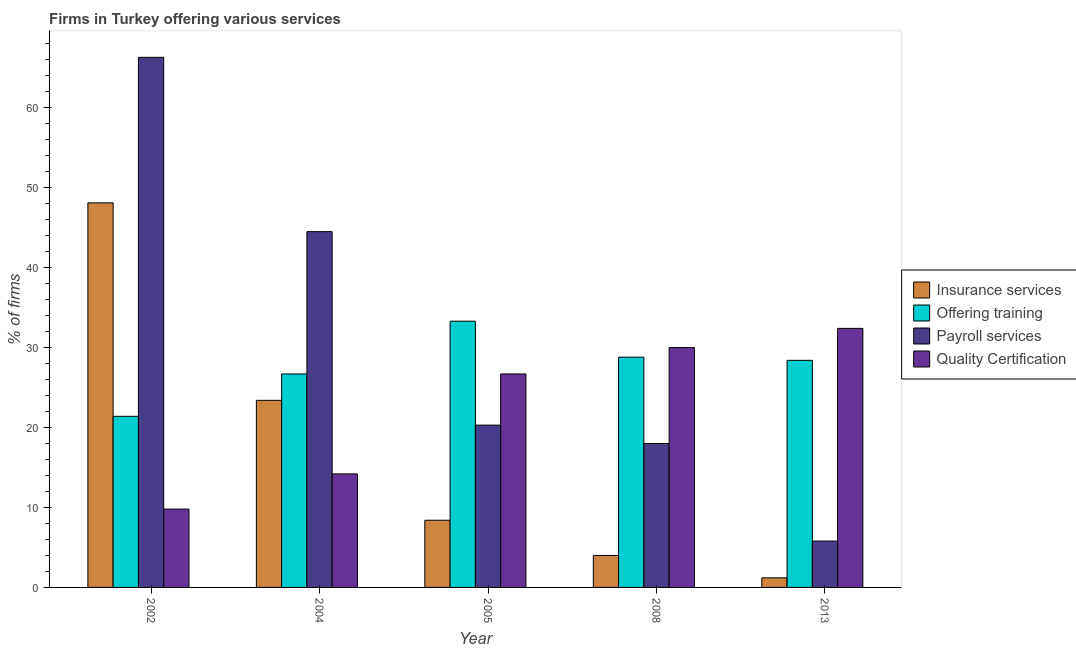How many different coloured bars are there?
Your response must be concise. 4. How many groups of bars are there?
Offer a very short reply. 5. How many bars are there on the 1st tick from the right?
Offer a very short reply. 4. What is the label of the 5th group of bars from the left?
Offer a terse response. 2013. In how many cases, is the number of bars for a given year not equal to the number of legend labels?
Your answer should be very brief. 0. What is the percentage of firms offering payroll services in 2002?
Ensure brevity in your answer.  66.3. Across all years, what is the maximum percentage of firms offering quality certification?
Provide a succinct answer. 32.4. Across all years, what is the minimum percentage of firms offering payroll services?
Offer a terse response. 5.8. In which year was the percentage of firms offering payroll services maximum?
Your answer should be very brief. 2002. In which year was the percentage of firms offering quality certification minimum?
Your response must be concise. 2002. What is the total percentage of firms offering training in the graph?
Make the answer very short. 138.6. What is the difference between the percentage of firms offering quality certification in 2005 and that in 2013?
Your answer should be compact. -5.7. What is the difference between the percentage of firms offering payroll services in 2008 and the percentage of firms offering insurance services in 2004?
Provide a succinct answer. -26.5. What is the average percentage of firms offering payroll services per year?
Offer a terse response. 30.98. In how many years, is the percentage of firms offering insurance services greater than 26 %?
Give a very brief answer. 1. What is the ratio of the percentage of firms offering insurance services in 2002 to that in 2005?
Keep it short and to the point. 5.73. Is the percentage of firms offering quality certification in 2002 less than that in 2013?
Provide a short and direct response. Yes. Is the difference between the percentage of firms offering payroll services in 2002 and 2008 greater than the difference between the percentage of firms offering quality certification in 2002 and 2008?
Your answer should be very brief. No. What is the difference between the highest and the second highest percentage of firms offering quality certification?
Ensure brevity in your answer.  2.4. What is the difference between the highest and the lowest percentage of firms offering insurance services?
Your response must be concise. 46.9. Is it the case that in every year, the sum of the percentage of firms offering training and percentage of firms offering insurance services is greater than the sum of percentage of firms offering payroll services and percentage of firms offering quality certification?
Make the answer very short. No. What does the 1st bar from the left in 2008 represents?
Provide a short and direct response. Insurance services. What does the 2nd bar from the right in 2008 represents?
Your answer should be compact. Payroll services. How many bars are there?
Ensure brevity in your answer.  20. Does the graph contain any zero values?
Your answer should be very brief. No. Where does the legend appear in the graph?
Provide a succinct answer. Center right. What is the title of the graph?
Your response must be concise. Firms in Turkey offering various services . What is the label or title of the X-axis?
Make the answer very short. Year. What is the label or title of the Y-axis?
Offer a very short reply. % of firms. What is the % of firms in Insurance services in 2002?
Provide a short and direct response. 48.1. What is the % of firms in Offering training in 2002?
Offer a terse response. 21.4. What is the % of firms of Payroll services in 2002?
Provide a succinct answer. 66.3. What is the % of firms in Quality Certification in 2002?
Offer a terse response. 9.8. What is the % of firms of Insurance services in 2004?
Offer a terse response. 23.4. What is the % of firms in Offering training in 2004?
Provide a short and direct response. 26.7. What is the % of firms of Payroll services in 2004?
Make the answer very short. 44.5. What is the % of firms in Insurance services in 2005?
Keep it short and to the point. 8.4. What is the % of firms of Offering training in 2005?
Your response must be concise. 33.3. What is the % of firms in Payroll services in 2005?
Give a very brief answer. 20.3. What is the % of firms of Quality Certification in 2005?
Make the answer very short. 26.7. What is the % of firms in Offering training in 2008?
Give a very brief answer. 28.8. What is the % of firms of Payroll services in 2008?
Your answer should be compact. 18. What is the % of firms of Insurance services in 2013?
Your answer should be compact. 1.2. What is the % of firms of Offering training in 2013?
Your response must be concise. 28.4. What is the % of firms in Quality Certification in 2013?
Keep it short and to the point. 32.4. Across all years, what is the maximum % of firms in Insurance services?
Your answer should be very brief. 48.1. Across all years, what is the maximum % of firms in Offering training?
Your answer should be compact. 33.3. Across all years, what is the maximum % of firms in Payroll services?
Provide a succinct answer. 66.3. Across all years, what is the maximum % of firms in Quality Certification?
Keep it short and to the point. 32.4. Across all years, what is the minimum % of firms of Offering training?
Offer a very short reply. 21.4. Across all years, what is the minimum % of firms of Payroll services?
Ensure brevity in your answer.  5.8. Across all years, what is the minimum % of firms in Quality Certification?
Your response must be concise. 9.8. What is the total % of firms in Insurance services in the graph?
Provide a succinct answer. 85.1. What is the total % of firms in Offering training in the graph?
Make the answer very short. 138.6. What is the total % of firms in Payroll services in the graph?
Give a very brief answer. 154.9. What is the total % of firms in Quality Certification in the graph?
Your answer should be very brief. 113.1. What is the difference between the % of firms in Insurance services in 2002 and that in 2004?
Provide a succinct answer. 24.7. What is the difference between the % of firms of Payroll services in 2002 and that in 2004?
Ensure brevity in your answer.  21.8. What is the difference between the % of firms of Quality Certification in 2002 and that in 2004?
Your answer should be very brief. -4.4. What is the difference between the % of firms of Insurance services in 2002 and that in 2005?
Give a very brief answer. 39.7. What is the difference between the % of firms of Offering training in 2002 and that in 2005?
Give a very brief answer. -11.9. What is the difference between the % of firms of Quality Certification in 2002 and that in 2005?
Your answer should be very brief. -16.9. What is the difference between the % of firms of Insurance services in 2002 and that in 2008?
Give a very brief answer. 44.1. What is the difference between the % of firms in Offering training in 2002 and that in 2008?
Provide a succinct answer. -7.4. What is the difference between the % of firms of Payroll services in 2002 and that in 2008?
Your answer should be compact. 48.3. What is the difference between the % of firms in Quality Certification in 2002 and that in 2008?
Your answer should be very brief. -20.2. What is the difference between the % of firms in Insurance services in 2002 and that in 2013?
Give a very brief answer. 46.9. What is the difference between the % of firms in Payroll services in 2002 and that in 2013?
Your answer should be compact. 60.5. What is the difference between the % of firms in Quality Certification in 2002 and that in 2013?
Offer a terse response. -22.6. What is the difference between the % of firms of Offering training in 2004 and that in 2005?
Offer a very short reply. -6.6. What is the difference between the % of firms in Payroll services in 2004 and that in 2005?
Your answer should be very brief. 24.2. What is the difference between the % of firms in Quality Certification in 2004 and that in 2005?
Keep it short and to the point. -12.5. What is the difference between the % of firms in Insurance services in 2004 and that in 2008?
Keep it short and to the point. 19.4. What is the difference between the % of firms in Quality Certification in 2004 and that in 2008?
Your answer should be very brief. -15.8. What is the difference between the % of firms of Offering training in 2004 and that in 2013?
Your response must be concise. -1.7. What is the difference between the % of firms in Payroll services in 2004 and that in 2013?
Give a very brief answer. 38.7. What is the difference between the % of firms of Quality Certification in 2004 and that in 2013?
Offer a terse response. -18.2. What is the difference between the % of firms of Offering training in 2005 and that in 2008?
Your answer should be compact. 4.5. What is the difference between the % of firms in Offering training in 2005 and that in 2013?
Ensure brevity in your answer.  4.9. What is the difference between the % of firms in Quality Certification in 2005 and that in 2013?
Make the answer very short. -5.7. What is the difference between the % of firms of Insurance services in 2008 and that in 2013?
Your answer should be very brief. 2.8. What is the difference between the % of firms in Offering training in 2008 and that in 2013?
Your response must be concise. 0.4. What is the difference between the % of firms of Payroll services in 2008 and that in 2013?
Make the answer very short. 12.2. What is the difference between the % of firms in Quality Certification in 2008 and that in 2013?
Your answer should be compact. -2.4. What is the difference between the % of firms of Insurance services in 2002 and the % of firms of Offering training in 2004?
Keep it short and to the point. 21.4. What is the difference between the % of firms of Insurance services in 2002 and the % of firms of Quality Certification in 2004?
Give a very brief answer. 33.9. What is the difference between the % of firms in Offering training in 2002 and the % of firms in Payroll services in 2004?
Make the answer very short. -23.1. What is the difference between the % of firms of Offering training in 2002 and the % of firms of Quality Certification in 2004?
Ensure brevity in your answer.  7.2. What is the difference between the % of firms in Payroll services in 2002 and the % of firms in Quality Certification in 2004?
Your answer should be very brief. 52.1. What is the difference between the % of firms of Insurance services in 2002 and the % of firms of Offering training in 2005?
Offer a very short reply. 14.8. What is the difference between the % of firms in Insurance services in 2002 and the % of firms in Payroll services in 2005?
Ensure brevity in your answer.  27.8. What is the difference between the % of firms of Insurance services in 2002 and the % of firms of Quality Certification in 2005?
Ensure brevity in your answer.  21.4. What is the difference between the % of firms in Payroll services in 2002 and the % of firms in Quality Certification in 2005?
Offer a very short reply. 39.6. What is the difference between the % of firms of Insurance services in 2002 and the % of firms of Offering training in 2008?
Give a very brief answer. 19.3. What is the difference between the % of firms in Insurance services in 2002 and the % of firms in Payroll services in 2008?
Keep it short and to the point. 30.1. What is the difference between the % of firms of Insurance services in 2002 and the % of firms of Quality Certification in 2008?
Keep it short and to the point. 18.1. What is the difference between the % of firms in Offering training in 2002 and the % of firms in Payroll services in 2008?
Make the answer very short. 3.4. What is the difference between the % of firms of Offering training in 2002 and the % of firms of Quality Certification in 2008?
Make the answer very short. -8.6. What is the difference between the % of firms in Payroll services in 2002 and the % of firms in Quality Certification in 2008?
Give a very brief answer. 36.3. What is the difference between the % of firms in Insurance services in 2002 and the % of firms in Payroll services in 2013?
Ensure brevity in your answer.  42.3. What is the difference between the % of firms of Offering training in 2002 and the % of firms of Quality Certification in 2013?
Give a very brief answer. -11. What is the difference between the % of firms of Payroll services in 2002 and the % of firms of Quality Certification in 2013?
Make the answer very short. 33.9. What is the difference between the % of firms in Insurance services in 2004 and the % of firms in Offering training in 2005?
Offer a very short reply. -9.9. What is the difference between the % of firms in Insurance services in 2004 and the % of firms in Quality Certification in 2005?
Offer a terse response. -3.3. What is the difference between the % of firms in Insurance services in 2004 and the % of firms in Offering training in 2008?
Provide a short and direct response. -5.4. What is the difference between the % of firms of Insurance services in 2004 and the % of firms of Payroll services in 2008?
Provide a succinct answer. 5.4. What is the difference between the % of firms of Offering training in 2004 and the % of firms of Payroll services in 2008?
Make the answer very short. 8.7. What is the difference between the % of firms in Insurance services in 2004 and the % of firms in Payroll services in 2013?
Provide a short and direct response. 17.6. What is the difference between the % of firms of Insurance services in 2004 and the % of firms of Quality Certification in 2013?
Your answer should be compact. -9. What is the difference between the % of firms of Offering training in 2004 and the % of firms of Payroll services in 2013?
Offer a very short reply. 20.9. What is the difference between the % of firms in Insurance services in 2005 and the % of firms in Offering training in 2008?
Your answer should be compact. -20.4. What is the difference between the % of firms in Insurance services in 2005 and the % of firms in Payroll services in 2008?
Ensure brevity in your answer.  -9.6. What is the difference between the % of firms in Insurance services in 2005 and the % of firms in Quality Certification in 2008?
Your response must be concise. -21.6. What is the difference between the % of firms in Offering training in 2005 and the % of firms in Quality Certification in 2008?
Provide a short and direct response. 3.3. What is the difference between the % of firms of Offering training in 2005 and the % of firms of Payroll services in 2013?
Ensure brevity in your answer.  27.5. What is the difference between the % of firms in Payroll services in 2005 and the % of firms in Quality Certification in 2013?
Offer a terse response. -12.1. What is the difference between the % of firms of Insurance services in 2008 and the % of firms of Offering training in 2013?
Provide a succinct answer. -24.4. What is the difference between the % of firms of Insurance services in 2008 and the % of firms of Quality Certification in 2013?
Keep it short and to the point. -28.4. What is the difference between the % of firms in Offering training in 2008 and the % of firms in Payroll services in 2013?
Your answer should be compact. 23. What is the difference between the % of firms of Payroll services in 2008 and the % of firms of Quality Certification in 2013?
Give a very brief answer. -14.4. What is the average % of firms in Insurance services per year?
Provide a short and direct response. 17.02. What is the average % of firms in Offering training per year?
Offer a very short reply. 27.72. What is the average % of firms in Payroll services per year?
Ensure brevity in your answer.  30.98. What is the average % of firms of Quality Certification per year?
Keep it short and to the point. 22.62. In the year 2002, what is the difference between the % of firms in Insurance services and % of firms in Offering training?
Keep it short and to the point. 26.7. In the year 2002, what is the difference between the % of firms in Insurance services and % of firms in Payroll services?
Offer a very short reply. -18.2. In the year 2002, what is the difference between the % of firms in Insurance services and % of firms in Quality Certification?
Ensure brevity in your answer.  38.3. In the year 2002, what is the difference between the % of firms of Offering training and % of firms of Payroll services?
Keep it short and to the point. -44.9. In the year 2002, what is the difference between the % of firms of Payroll services and % of firms of Quality Certification?
Offer a terse response. 56.5. In the year 2004, what is the difference between the % of firms in Insurance services and % of firms in Payroll services?
Make the answer very short. -21.1. In the year 2004, what is the difference between the % of firms of Offering training and % of firms of Payroll services?
Give a very brief answer. -17.8. In the year 2004, what is the difference between the % of firms of Offering training and % of firms of Quality Certification?
Offer a very short reply. 12.5. In the year 2004, what is the difference between the % of firms of Payroll services and % of firms of Quality Certification?
Offer a very short reply. 30.3. In the year 2005, what is the difference between the % of firms of Insurance services and % of firms of Offering training?
Ensure brevity in your answer.  -24.9. In the year 2005, what is the difference between the % of firms in Insurance services and % of firms in Payroll services?
Give a very brief answer. -11.9. In the year 2005, what is the difference between the % of firms of Insurance services and % of firms of Quality Certification?
Your response must be concise. -18.3. In the year 2005, what is the difference between the % of firms of Offering training and % of firms of Payroll services?
Make the answer very short. 13. In the year 2005, what is the difference between the % of firms in Payroll services and % of firms in Quality Certification?
Give a very brief answer. -6.4. In the year 2008, what is the difference between the % of firms in Insurance services and % of firms in Offering training?
Keep it short and to the point. -24.8. In the year 2008, what is the difference between the % of firms of Insurance services and % of firms of Quality Certification?
Offer a very short reply. -26. In the year 2008, what is the difference between the % of firms in Offering training and % of firms in Quality Certification?
Your answer should be compact. -1.2. In the year 2008, what is the difference between the % of firms in Payroll services and % of firms in Quality Certification?
Provide a succinct answer. -12. In the year 2013, what is the difference between the % of firms of Insurance services and % of firms of Offering training?
Offer a terse response. -27.2. In the year 2013, what is the difference between the % of firms of Insurance services and % of firms of Payroll services?
Your response must be concise. -4.6. In the year 2013, what is the difference between the % of firms in Insurance services and % of firms in Quality Certification?
Your answer should be very brief. -31.2. In the year 2013, what is the difference between the % of firms of Offering training and % of firms of Payroll services?
Keep it short and to the point. 22.6. In the year 2013, what is the difference between the % of firms in Offering training and % of firms in Quality Certification?
Ensure brevity in your answer.  -4. In the year 2013, what is the difference between the % of firms of Payroll services and % of firms of Quality Certification?
Your answer should be very brief. -26.6. What is the ratio of the % of firms of Insurance services in 2002 to that in 2004?
Offer a very short reply. 2.06. What is the ratio of the % of firms in Offering training in 2002 to that in 2004?
Make the answer very short. 0.8. What is the ratio of the % of firms in Payroll services in 2002 to that in 2004?
Give a very brief answer. 1.49. What is the ratio of the % of firms of Quality Certification in 2002 to that in 2004?
Your answer should be compact. 0.69. What is the ratio of the % of firms in Insurance services in 2002 to that in 2005?
Offer a very short reply. 5.73. What is the ratio of the % of firms in Offering training in 2002 to that in 2005?
Make the answer very short. 0.64. What is the ratio of the % of firms of Payroll services in 2002 to that in 2005?
Your answer should be very brief. 3.27. What is the ratio of the % of firms of Quality Certification in 2002 to that in 2005?
Ensure brevity in your answer.  0.37. What is the ratio of the % of firms of Insurance services in 2002 to that in 2008?
Your response must be concise. 12.03. What is the ratio of the % of firms of Offering training in 2002 to that in 2008?
Offer a very short reply. 0.74. What is the ratio of the % of firms of Payroll services in 2002 to that in 2008?
Your answer should be very brief. 3.68. What is the ratio of the % of firms in Quality Certification in 2002 to that in 2008?
Keep it short and to the point. 0.33. What is the ratio of the % of firms in Insurance services in 2002 to that in 2013?
Provide a short and direct response. 40.08. What is the ratio of the % of firms of Offering training in 2002 to that in 2013?
Offer a very short reply. 0.75. What is the ratio of the % of firms in Payroll services in 2002 to that in 2013?
Provide a short and direct response. 11.43. What is the ratio of the % of firms of Quality Certification in 2002 to that in 2013?
Provide a short and direct response. 0.3. What is the ratio of the % of firms of Insurance services in 2004 to that in 2005?
Provide a short and direct response. 2.79. What is the ratio of the % of firms of Offering training in 2004 to that in 2005?
Your response must be concise. 0.8. What is the ratio of the % of firms of Payroll services in 2004 to that in 2005?
Offer a terse response. 2.19. What is the ratio of the % of firms in Quality Certification in 2004 to that in 2005?
Your answer should be compact. 0.53. What is the ratio of the % of firms in Insurance services in 2004 to that in 2008?
Your response must be concise. 5.85. What is the ratio of the % of firms in Offering training in 2004 to that in 2008?
Provide a succinct answer. 0.93. What is the ratio of the % of firms in Payroll services in 2004 to that in 2008?
Keep it short and to the point. 2.47. What is the ratio of the % of firms in Quality Certification in 2004 to that in 2008?
Your answer should be very brief. 0.47. What is the ratio of the % of firms in Insurance services in 2004 to that in 2013?
Provide a short and direct response. 19.5. What is the ratio of the % of firms in Offering training in 2004 to that in 2013?
Your response must be concise. 0.94. What is the ratio of the % of firms of Payroll services in 2004 to that in 2013?
Ensure brevity in your answer.  7.67. What is the ratio of the % of firms in Quality Certification in 2004 to that in 2013?
Make the answer very short. 0.44. What is the ratio of the % of firms of Offering training in 2005 to that in 2008?
Make the answer very short. 1.16. What is the ratio of the % of firms of Payroll services in 2005 to that in 2008?
Your answer should be compact. 1.13. What is the ratio of the % of firms in Quality Certification in 2005 to that in 2008?
Your answer should be compact. 0.89. What is the ratio of the % of firms in Insurance services in 2005 to that in 2013?
Ensure brevity in your answer.  7. What is the ratio of the % of firms of Offering training in 2005 to that in 2013?
Provide a succinct answer. 1.17. What is the ratio of the % of firms in Quality Certification in 2005 to that in 2013?
Ensure brevity in your answer.  0.82. What is the ratio of the % of firms of Offering training in 2008 to that in 2013?
Give a very brief answer. 1.01. What is the ratio of the % of firms in Payroll services in 2008 to that in 2013?
Make the answer very short. 3.1. What is the ratio of the % of firms in Quality Certification in 2008 to that in 2013?
Make the answer very short. 0.93. What is the difference between the highest and the second highest % of firms in Insurance services?
Your answer should be very brief. 24.7. What is the difference between the highest and the second highest % of firms of Payroll services?
Your answer should be very brief. 21.8. What is the difference between the highest and the second highest % of firms in Quality Certification?
Your answer should be compact. 2.4. What is the difference between the highest and the lowest % of firms in Insurance services?
Offer a very short reply. 46.9. What is the difference between the highest and the lowest % of firms in Payroll services?
Provide a short and direct response. 60.5. What is the difference between the highest and the lowest % of firms of Quality Certification?
Ensure brevity in your answer.  22.6. 